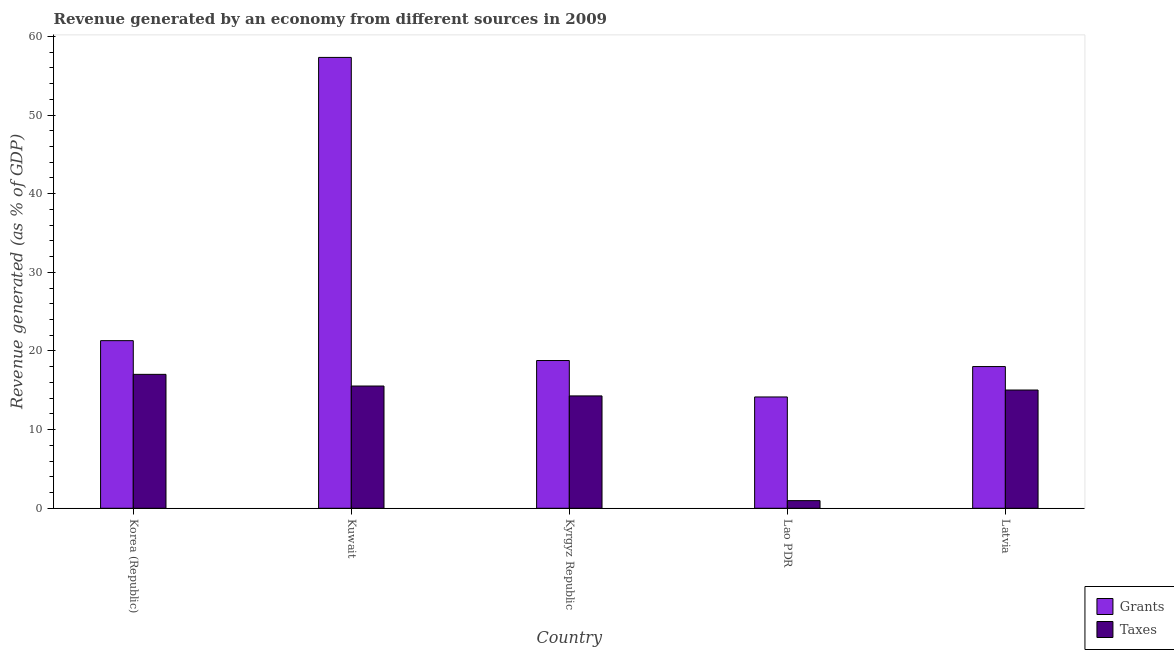How many groups of bars are there?
Ensure brevity in your answer.  5. Are the number of bars on each tick of the X-axis equal?
Ensure brevity in your answer.  Yes. How many bars are there on the 2nd tick from the left?
Your answer should be very brief. 2. How many bars are there on the 5th tick from the right?
Your response must be concise. 2. What is the label of the 2nd group of bars from the left?
Provide a succinct answer. Kuwait. In how many cases, is the number of bars for a given country not equal to the number of legend labels?
Your answer should be very brief. 0. What is the revenue generated by grants in Kyrgyz Republic?
Provide a succinct answer. 18.79. Across all countries, what is the maximum revenue generated by taxes?
Your answer should be compact. 17.03. Across all countries, what is the minimum revenue generated by grants?
Provide a short and direct response. 14.15. In which country was the revenue generated by grants maximum?
Keep it short and to the point. Kuwait. In which country was the revenue generated by taxes minimum?
Keep it short and to the point. Lao PDR. What is the total revenue generated by grants in the graph?
Your answer should be very brief. 129.6. What is the difference between the revenue generated by taxes in Kuwait and that in Latvia?
Give a very brief answer. 0.51. What is the difference between the revenue generated by taxes in Kyrgyz Republic and the revenue generated by grants in Latvia?
Provide a succinct answer. -3.73. What is the average revenue generated by grants per country?
Keep it short and to the point. 25.92. What is the difference between the revenue generated by grants and revenue generated by taxes in Lao PDR?
Provide a succinct answer. 13.18. In how many countries, is the revenue generated by grants greater than 22 %?
Keep it short and to the point. 1. What is the ratio of the revenue generated by taxes in Kuwait to that in Lao PDR?
Offer a terse response. 16.01. Is the revenue generated by taxes in Kuwait less than that in Kyrgyz Republic?
Give a very brief answer. No. What is the difference between the highest and the second highest revenue generated by grants?
Provide a short and direct response. 36.02. What is the difference between the highest and the lowest revenue generated by grants?
Your answer should be very brief. 43.18. In how many countries, is the revenue generated by grants greater than the average revenue generated by grants taken over all countries?
Your response must be concise. 1. What does the 1st bar from the left in Kyrgyz Republic represents?
Offer a terse response. Grants. What does the 1st bar from the right in Kyrgyz Republic represents?
Keep it short and to the point. Taxes. How many bars are there?
Make the answer very short. 10. Are all the bars in the graph horizontal?
Make the answer very short. No. How many countries are there in the graph?
Provide a short and direct response. 5. Does the graph contain any zero values?
Make the answer very short. No. How many legend labels are there?
Make the answer very short. 2. What is the title of the graph?
Keep it short and to the point. Revenue generated by an economy from different sources in 2009. What is the label or title of the X-axis?
Ensure brevity in your answer.  Country. What is the label or title of the Y-axis?
Provide a succinct answer. Revenue generated (as % of GDP). What is the Revenue generated (as % of GDP) of Grants in Korea (Republic)?
Provide a succinct answer. 21.31. What is the Revenue generated (as % of GDP) of Taxes in Korea (Republic)?
Give a very brief answer. 17.03. What is the Revenue generated (as % of GDP) in Grants in Kuwait?
Ensure brevity in your answer.  57.33. What is the Revenue generated (as % of GDP) of Taxes in Kuwait?
Offer a terse response. 15.55. What is the Revenue generated (as % of GDP) in Grants in Kyrgyz Republic?
Offer a terse response. 18.79. What is the Revenue generated (as % of GDP) of Taxes in Kyrgyz Republic?
Ensure brevity in your answer.  14.29. What is the Revenue generated (as % of GDP) of Grants in Lao PDR?
Ensure brevity in your answer.  14.15. What is the Revenue generated (as % of GDP) in Taxes in Lao PDR?
Your answer should be very brief. 0.97. What is the Revenue generated (as % of GDP) of Grants in Latvia?
Provide a short and direct response. 18.02. What is the Revenue generated (as % of GDP) of Taxes in Latvia?
Provide a short and direct response. 15.04. Across all countries, what is the maximum Revenue generated (as % of GDP) of Grants?
Your answer should be compact. 57.33. Across all countries, what is the maximum Revenue generated (as % of GDP) in Taxes?
Your answer should be compact. 17.03. Across all countries, what is the minimum Revenue generated (as % of GDP) in Grants?
Ensure brevity in your answer.  14.15. Across all countries, what is the minimum Revenue generated (as % of GDP) in Taxes?
Provide a short and direct response. 0.97. What is the total Revenue generated (as % of GDP) of Grants in the graph?
Provide a succinct answer. 129.6. What is the total Revenue generated (as % of GDP) in Taxes in the graph?
Provide a succinct answer. 62.87. What is the difference between the Revenue generated (as % of GDP) of Grants in Korea (Republic) and that in Kuwait?
Your answer should be very brief. -36.02. What is the difference between the Revenue generated (as % of GDP) of Taxes in Korea (Republic) and that in Kuwait?
Your response must be concise. 1.48. What is the difference between the Revenue generated (as % of GDP) of Grants in Korea (Republic) and that in Kyrgyz Republic?
Give a very brief answer. 2.53. What is the difference between the Revenue generated (as % of GDP) in Taxes in Korea (Republic) and that in Kyrgyz Republic?
Offer a terse response. 2.74. What is the difference between the Revenue generated (as % of GDP) of Grants in Korea (Republic) and that in Lao PDR?
Give a very brief answer. 7.16. What is the difference between the Revenue generated (as % of GDP) of Taxes in Korea (Republic) and that in Lao PDR?
Ensure brevity in your answer.  16.06. What is the difference between the Revenue generated (as % of GDP) in Grants in Korea (Republic) and that in Latvia?
Ensure brevity in your answer.  3.29. What is the difference between the Revenue generated (as % of GDP) of Taxes in Korea (Republic) and that in Latvia?
Offer a terse response. 1.99. What is the difference between the Revenue generated (as % of GDP) in Grants in Kuwait and that in Kyrgyz Republic?
Ensure brevity in your answer.  38.54. What is the difference between the Revenue generated (as % of GDP) of Taxes in Kuwait and that in Kyrgyz Republic?
Your answer should be compact. 1.26. What is the difference between the Revenue generated (as % of GDP) in Grants in Kuwait and that in Lao PDR?
Offer a very short reply. 43.18. What is the difference between the Revenue generated (as % of GDP) in Taxes in Kuwait and that in Lao PDR?
Provide a succinct answer. 14.57. What is the difference between the Revenue generated (as % of GDP) in Grants in Kuwait and that in Latvia?
Your answer should be compact. 39.31. What is the difference between the Revenue generated (as % of GDP) of Taxes in Kuwait and that in Latvia?
Your response must be concise. 0.51. What is the difference between the Revenue generated (as % of GDP) in Grants in Kyrgyz Republic and that in Lao PDR?
Provide a succinct answer. 4.63. What is the difference between the Revenue generated (as % of GDP) in Taxes in Kyrgyz Republic and that in Lao PDR?
Offer a terse response. 13.32. What is the difference between the Revenue generated (as % of GDP) in Grants in Kyrgyz Republic and that in Latvia?
Keep it short and to the point. 0.77. What is the difference between the Revenue generated (as % of GDP) of Taxes in Kyrgyz Republic and that in Latvia?
Offer a very short reply. -0.75. What is the difference between the Revenue generated (as % of GDP) of Grants in Lao PDR and that in Latvia?
Offer a terse response. -3.87. What is the difference between the Revenue generated (as % of GDP) in Taxes in Lao PDR and that in Latvia?
Ensure brevity in your answer.  -14.06. What is the difference between the Revenue generated (as % of GDP) in Grants in Korea (Republic) and the Revenue generated (as % of GDP) in Taxes in Kuwait?
Offer a terse response. 5.77. What is the difference between the Revenue generated (as % of GDP) of Grants in Korea (Republic) and the Revenue generated (as % of GDP) of Taxes in Kyrgyz Republic?
Ensure brevity in your answer.  7.03. What is the difference between the Revenue generated (as % of GDP) in Grants in Korea (Republic) and the Revenue generated (as % of GDP) in Taxes in Lao PDR?
Make the answer very short. 20.34. What is the difference between the Revenue generated (as % of GDP) in Grants in Korea (Republic) and the Revenue generated (as % of GDP) in Taxes in Latvia?
Provide a short and direct response. 6.28. What is the difference between the Revenue generated (as % of GDP) in Grants in Kuwait and the Revenue generated (as % of GDP) in Taxes in Kyrgyz Republic?
Offer a terse response. 43.04. What is the difference between the Revenue generated (as % of GDP) in Grants in Kuwait and the Revenue generated (as % of GDP) in Taxes in Lao PDR?
Your response must be concise. 56.36. What is the difference between the Revenue generated (as % of GDP) in Grants in Kuwait and the Revenue generated (as % of GDP) in Taxes in Latvia?
Ensure brevity in your answer.  42.29. What is the difference between the Revenue generated (as % of GDP) in Grants in Kyrgyz Republic and the Revenue generated (as % of GDP) in Taxes in Lao PDR?
Keep it short and to the point. 17.82. What is the difference between the Revenue generated (as % of GDP) in Grants in Kyrgyz Republic and the Revenue generated (as % of GDP) in Taxes in Latvia?
Your answer should be very brief. 3.75. What is the difference between the Revenue generated (as % of GDP) in Grants in Lao PDR and the Revenue generated (as % of GDP) in Taxes in Latvia?
Make the answer very short. -0.88. What is the average Revenue generated (as % of GDP) of Grants per country?
Ensure brevity in your answer.  25.92. What is the average Revenue generated (as % of GDP) of Taxes per country?
Ensure brevity in your answer.  12.57. What is the difference between the Revenue generated (as % of GDP) of Grants and Revenue generated (as % of GDP) of Taxes in Korea (Republic)?
Ensure brevity in your answer.  4.28. What is the difference between the Revenue generated (as % of GDP) in Grants and Revenue generated (as % of GDP) in Taxes in Kuwait?
Make the answer very short. 41.78. What is the difference between the Revenue generated (as % of GDP) in Grants and Revenue generated (as % of GDP) in Taxes in Kyrgyz Republic?
Give a very brief answer. 4.5. What is the difference between the Revenue generated (as % of GDP) in Grants and Revenue generated (as % of GDP) in Taxes in Lao PDR?
Provide a succinct answer. 13.18. What is the difference between the Revenue generated (as % of GDP) in Grants and Revenue generated (as % of GDP) in Taxes in Latvia?
Offer a very short reply. 2.98. What is the ratio of the Revenue generated (as % of GDP) of Grants in Korea (Republic) to that in Kuwait?
Give a very brief answer. 0.37. What is the ratio of the Revenue generated (as % of GDP) in Taxes in Korea (Republic) to that in Kuwait?
Your answer should be compact. 1.1. What is the ratio of the Revenue generated (as % of GDP) in Grants in Korea (Republic) to that in Kyrgyz Republic?
Give a very brief answer. 1.13. What is the ratio of the Revenue generated (as % of GDP) of Taxes in Korea (Republic) to that in Kyrgyz Republic?
Your answer should be very brief. 1.19. What is the ratio of the Revenue generated (as % of GDP) in Grants in Korea (Republic) to that in Lao PDR?
Ensure brevity in your answer.  1.51. What is the ratio of the Revenue generated (as % of GDP) of Taxes in Korea (Republic) to that in Lao PDR?
Make the answer very short. 17.53. What is the ratio of the Revenue generated (as % of GDP) of Grants in Korea (Republic) to that in Latvia?
Ensure brevity in your answer.  1.18. What is the ratio of the Revenue generated (as % of GDP) of Taxes in Korea (Republic) to that in Latvia?
Ensure brevity in your answer.  1.13. What is the ratio of the Revenue generated (as % of GDP) of Grants in Kuwait to that in Kyrgyz Republic?
Your answer should be very brief. 3.05. What is the ratio of the Revenue generated (as % of GDP) of Taxes in Kuwait to that in Kyrgyz Republic?
Your response must be concise. 1.09. What is the ratio of the Revenue generated (as % of GDP) of Grants in Kuwait to that in Lao PDR?
Your response must be concise. 4.05. What is the ratio of the Revenue generated (as % of GDP) in Taxes in Kuwait to that in Lao PDR?
Your answer should be compact. 16.01. What is the ratio of the Revenue generated (as % of GDP) of Grants in Kuwait to that in Latvia?
Provide a short and direct response. 3.18. What is the ratio of the Revenue generated (as % of GDP) of Taxes in Kuwait to that in Latvia?
Offer a very short reply. 1.03. What is the ratio of the Revenue generated (as % of GDP) in Grants in Kyrgyz Republic to that in Lao PDR?
Make the answer very short. 1.33. What is the ratio of the Revenue generated (as % of GDP) of Taxes in Kyrgyz Republic to that in Lao PDR?
Provide a short and direct response. 14.71. What is the ratio of the Revenue generated (as % of GDP) in Grants in Kyrgyz Republic to that in Latvia?
Provide a succinct answer. 1.04. What is the ratio of the Revenue generated (as % of GDP) of Taxes in Kyrgyz Republic to that in Latvia?
Offer a terse response. 0.95. What is the ratio of the Revenue generated (as % of GDP) of Grants in Lao PDR to that in Latvia?
Make the answer very short. 0.79. What is the ratio of the Revenue generated (as % of GDP) in Taxes in Lao PDR to that in Latvia?
Your answer should be very brief. 0.06. What is the difference between the highest and the second highest Revenue generated (as % of GDP) in Grants?
Offer a terse response. 36.02. What is the difference between the highest and the second highest Revenue generated (as % of GDP) in Taxes?
Keep it short and to the point. 1.48. What is the difference between the highest and the lowest Revenue generated (as % of GDP) in Grants?
Make the answer very short. 43.18. What is the difference between the highest and the lowest Revenue generated (as % of GDP) in Taxes?
Provide a short and direct response. 16.06. 